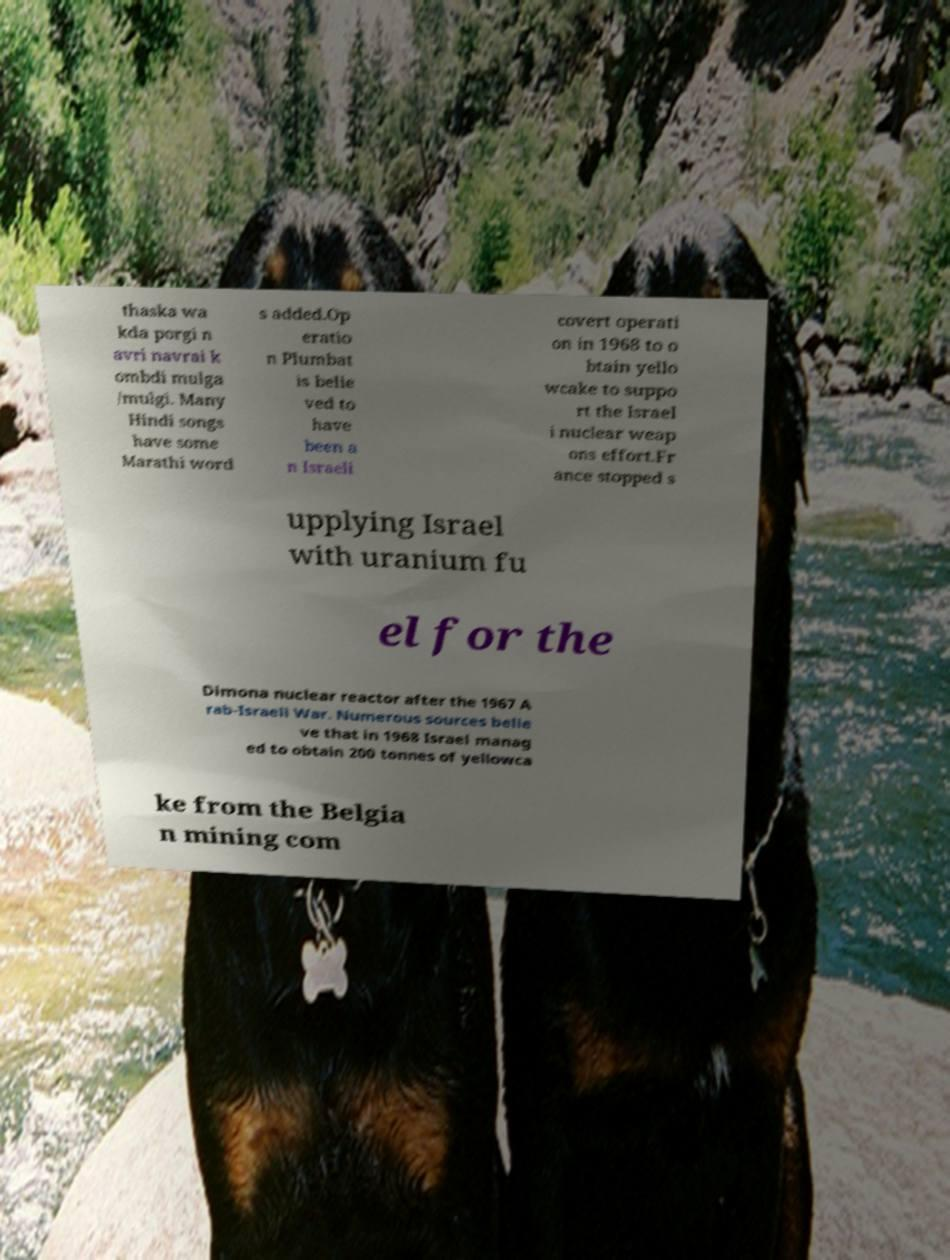For documentation purposes, I need the text within this image transcribed. Could you provide that? thaska wa kda porgi n avri navrai k ombdi mulga /mulgi. Many Hindi songs have some Marathi word s added.Op eratio n Plumbat is belie ved to have been a n Israeli covert operati on in 1968 to o btain yello wcake to suppo rt the Israel i nuclear weap ons effort.Fr ance stopped s upplying Israel with uranium fu el for the Dimona nuclear reactor after the 1967 A rab-Israeli War. Numerous sources belie ve that in 1968 Israel manag ed to obtain 200 tonnes of yellowca ke from the Belgia n mining com 